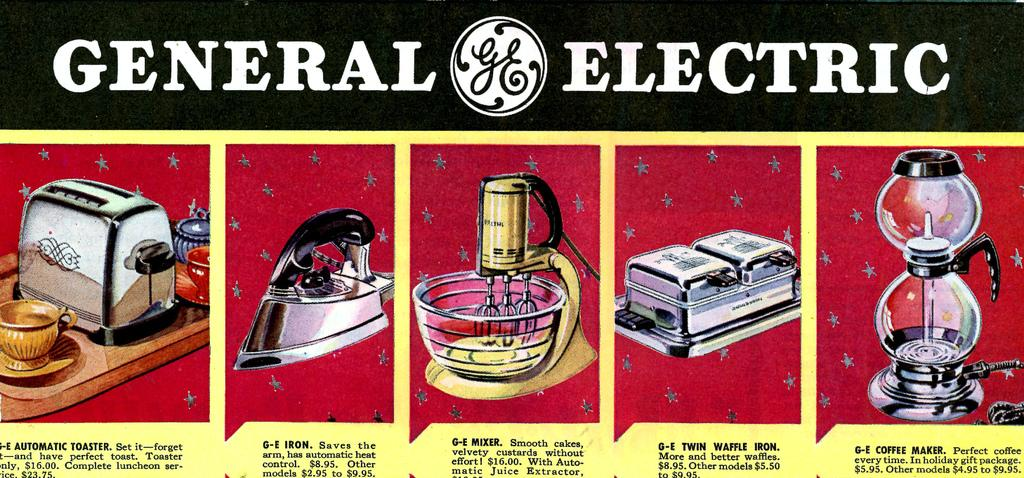<image>
Relay a brief, clear account of the picture shown. A vintage General Electric advertisement for household appliances. 